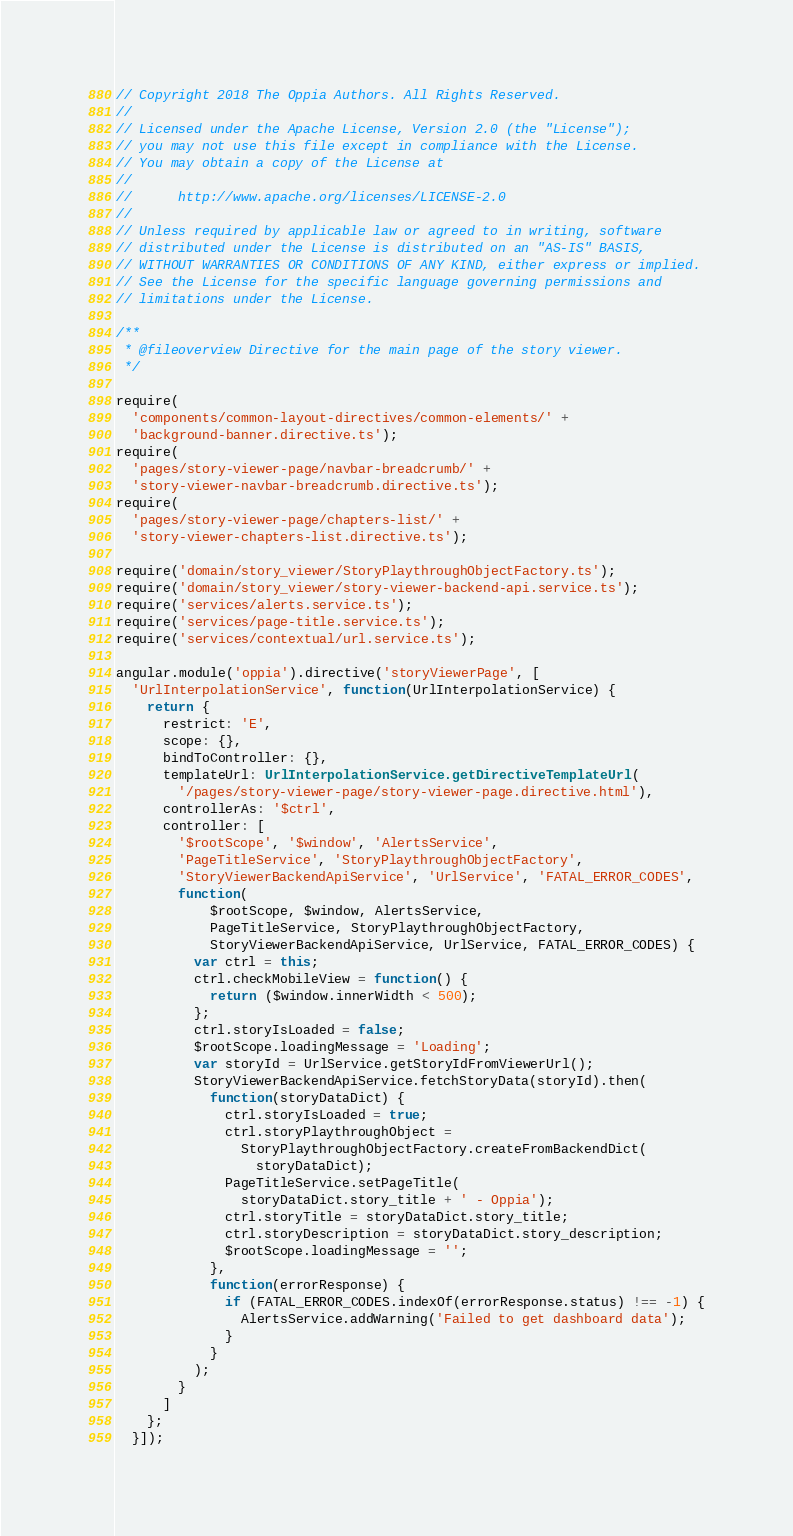Convert code to text. <code><loc_0><loc_0><loc_500><loc_500><_TypeScript_>// Copyright 2018 The Oppia Authors. All Rights Reserved.
//
// Licensed under the Apache License, Version 2.0 (the "License");
// you may not use this file except in compliance with the License.
// You may obtain a copy of the License at
//
//      http://www.apache.org/licenses/LICENSE-2.0
//
// Unless required by applicable law or agreed to in writing, software
// distributed under the License is distributed on an "AS-IS" BASIS,
// WITHOUT WARRANTIES OR CONDITIONS OF ANY KIND, either express or implied.
// See the License for the specific language governing permissions and
// limitations under the License.

/**
 * @fileoverview Directive for the main page of the story viewer.
 */

require(
  'components/common-layout-directives/common-elements/' +
  'background-banner.directive.ts');
require(
  'pages/story-viewer-page/navbar-breadcrumb/' +
  'story-viewer-navbar-breadcrumb.directive.ts');
require(
  'pages/story-viewer-page/chapters-list/' +
  'story-viewer-chapters-list.directive.ts');

require('domain/story_viewer/StoryPlaythroughObjectFactory.ts');
require('domain/story_viewer/story-viewer-backend-api.service.ts');
require('services/alerts.service.ts');
require('services/page-title.service.ts');
require('services/contextual/url.service.ts');

angular.module('oppia').directive('storyViewerPage', [
  'UrlInterpolationService', function(UrlInterpolationService) {
    return {
      restrict: 'E',
      scope: {},
      bindToController: {},
      templateUrl: UrlInterpolationService.getDirectiveTemplateUrl(
        '/pages/story-viewer-page/story-viewer-page.directive.html'),
      controllerAs: '$ctrl',
      controller: [
        '$rootScope', '$window', 'AlertsService',
        'PageTitleService', 'StoryPlaythroughObjectFactory',
        'StoryViewerBackendApiService', 'UrlService', 'FATAL_ERROR_CODES',
        function(
            $rootScope, $window, AlertsService,
            PageTitleService, StoryPlaythroughObjectFactory,
            StoryViewerBackendApiService, UrlService, FATAL_ERROR_CODES) {
          var ctrl = this;
          ctrl.checkMobileView = function() {
            return ($window.innerWidth < 500);
          };
          ctrl.storyIsLoaded = false;
          $rootScope.loadingMessage = 'Loading';
          var storyId = UrlService.getStoryIdFromViewerUrl();
          StoryViewerBackendApiService.fetchStoryData(storyId).then(
            function(storyDataDict) {
              ctrl.storyIsLoaded = true;
              ctrl.storyPlaythroughObject =
                StoryPlaythroughObjectFactory.createFromBackendDict(
                  storyDataDict);
              PageTitleService.setPageTitle(
                storyDataDict.story_title + ' - Oppia');
              ctrl.storyTitle = storyDataDict.story_title;
              ctrl.storyDescription = storyDataDict.story_description;
              $rootScope.loadingMessage = '';
            },
            function(errorResponse) {
              if (FATAL_ERROR_CODES.indexOf(errorResponse.status) !== -1) {
                AlertsService.addWarning('Failed to get dashboard data');
              }
            }
          );
        }
      ]
    };
  }]);
</code> 